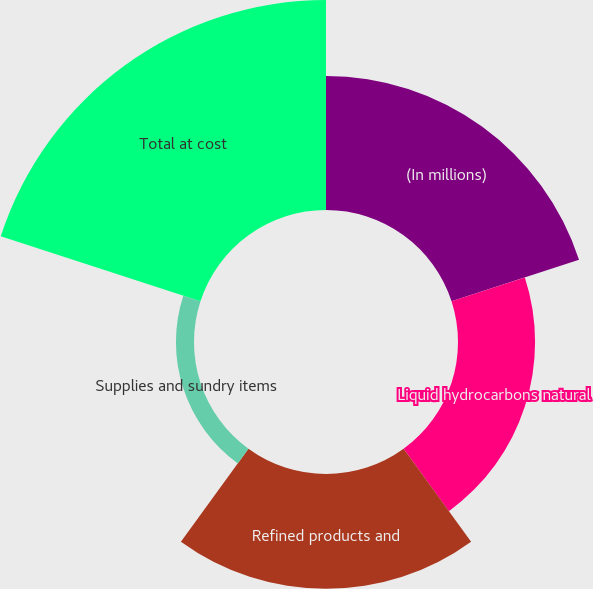Convert chart to OTSL. <chart><loc_0><loc_0><loc_500><loc_500><pie_chart><fcel>(In millions)<fcel>Liquid hydrocarbons natural<fcel>Refined products and<fcel>Supplies and sundry items<fcel>Total at cost<nl><fcel>24.19%<fcel>13.91%<fcel>20.73%<fcel>3.26%<fcel>37.9%<nl></chart> 